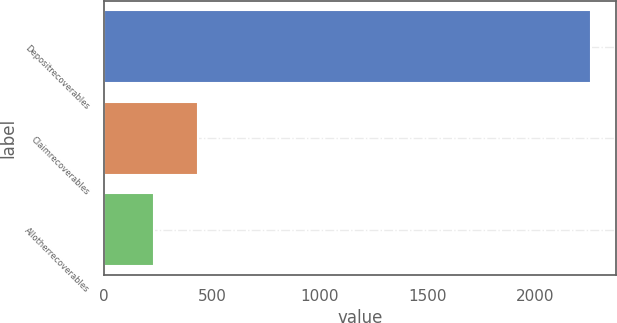Convert chart. <chart><loc_0><loc_0><loc_500><loc_500><bar_chart><fcel>Depositrecoverables<fcel>Claimrecoverables<fcel>Allotherrecoverables<nl><fcel>2258<fcel>434.6<fcel>232<nl></chart> 